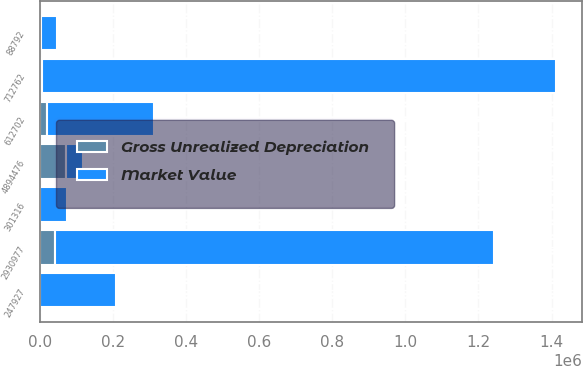Convert chart. <chart><loc_0><loc_0><loc_500><loc_500><stacked_bar_chart><ecel><fcel>247927<fcel>2930977<fcel>612702<fcel>88792<fcel>301316<fcel>712762<fcel>4894476<nl><fcel>Gross Unrealized Depreciation<fcel>962<fcel>42480<fcel>20154<fcel>1945<fcel>1467<fcel>5408<fcel>72416<nl><fcel>Market Value<fcel>206113<fcel>1.20041e+06<fcel>292245<fcel>45693<fcel>72780<fcel>1.40789e+06<fcel>45693<nl></chart> 